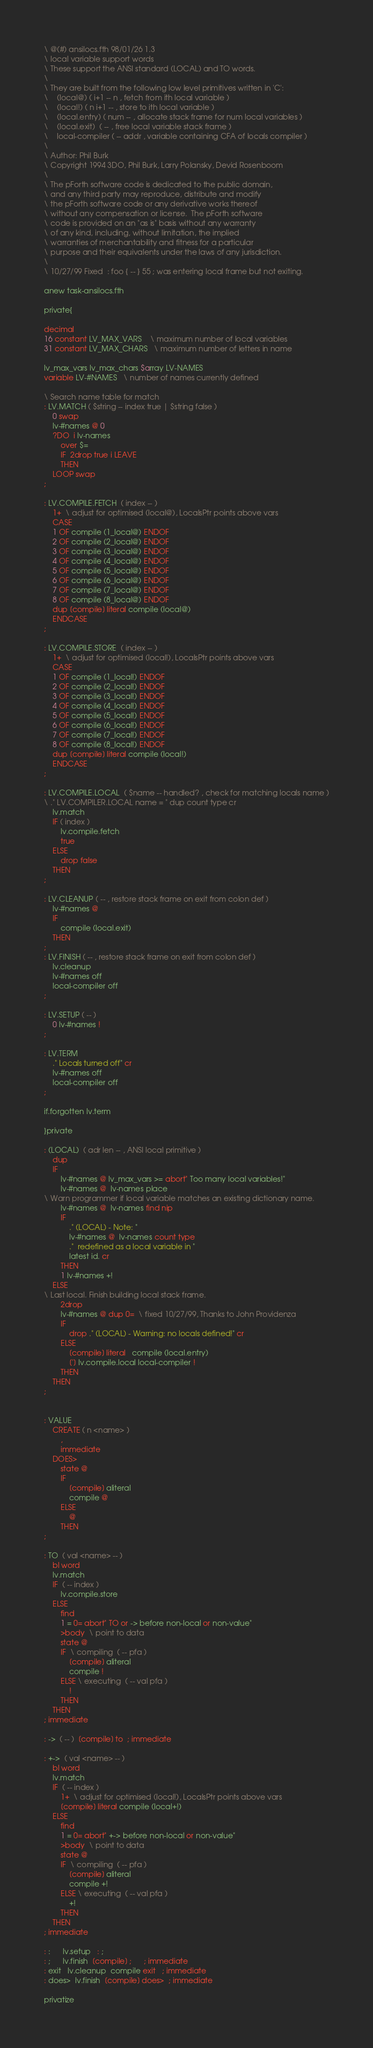Convert code to text. <code><loc_0><loc_0><loc_500><loc_500><_Forth_>\ @(#) ansilocs.fth 98/01/26 1.3
\ local variable support words
\ These support the ANSI standard (LOCAL) and TO words.
\
\ They are built from the following low level primitives written in 'C':
\    (local@) ( i+1 -- n , fetch from ith local variable )
\    (local!) ( n i+1 -- , store to ith local variable )
\    (local.entry) ( num -- , allocate stack frame for num local variables )
\    (local.exit)  ( -- , free local variable stack frame )
\    local-compiler ( -- addr , variable containing CFA of locals compiler )
\
\ Author: Phil Burk
\ Copyright 1994 3DO, Phil Burk, Larry Polansky, Devid Rosenboom
\
\ The pForth software code is dedicated to the public domain,
\ and any third party may reproduce, distribute and modify
\ the pForth software code or any derivative works thereof
\ without any compensation or license.  The pForth software
\ code is provided on an "as is" basis without any warranty
\ of any kind, including, without limitation, the implied
\ warranties of merchantability and fitness for a particular
\ purpose and their equivalents under the laws of any jurisdiction.
\
\ 10/27/99 Fixed  : foo { -- } 55 ; was entering local frame but not exiting.

anew task-ansilocs.fth

private{

decimal
16 constant LV_MAX_VARS    \ maximum number of local variables
31 constant LV_MAX_CHARS   \ maximum number of letters in name

lv_max_vars lv_max_chars $array LV-NAMES
variable LV-#NAMES   \ number of names currently defined

\ Search name table for match
: LV.MATCH ( $string -- index true | $string false )
    0 swap
    lv-#names @ 0
    ?DO  i lv-names
        over $=
        IF  2drop true i LEAVE
        THEN
    LOOP swap
;

: LV.COMPILE.FETCH  ( index -- )
	1+  \ adjust for optimised (local@), LocalsPtr points above vars
	CASE
	1 OF compile (1_local@) ENDOF
	2 OF compile (2_local@) ENDOF
	3 OF compile (3_local@) ENDOF
	4 OF compile (4_local@) ENDOF
	5 OF compile (5_local@) ENDOF
	6 OF compile (6_local@) ENDOF
	7 OF compile (7_local@) ENDOF
	8 OF compile (8_local@) ENDOF
	dup [compile] literal compile (local@)
	ENDCASE
;

: LV.COMPILE.STORE  ( index -- )
	1+  \ adjust for optimised (local!), LocalsPtr points above vars
	CASE
	1 OF compile (1_local!) ENDOF
	2 OF compile (2_local!) ENDOF
	3 OF compile (3_local!) ENDOF
	4 OF compile (4_local!) ENDOF
	5 OF compile (5_local!) ENDOF
	6 OF compile (6_local!) ENDOF
	7 OF compile (7_local!) ENDOF
	8 OF compile (8_local!) ENDOF
	dup [compile] literal compile (local!)
	ENDCASE
;

: LV.COMPILE.LOCAL  ( $name -- handled? , check for matching locals name )
\ ." LV.COMPILER.LOCAL name = " dup count type cr
	lv.match
	IF ( index )
		lv.compile.fetch
		true
	ELSE
		drop false
	THEN
;

: LV.CLEANUP ( -- , restore stack frame on exit from colon def )
	lv-#names @
	IF
		compile (local.exit)
	THEN
;
: LV.FINISH ( -- , restore stack frame on exit from colon def )
	lv.cleanup
	lv-#names off
	local-compiler off
;

: LV.SETUP ( -- )
	0 lv-#names !
;

: LV.TERM
	." Locals turned off" cr
	lv-#names off
	local-compiler off
;

if.forgotten lv.term

}private

: (LOCAL)  ( adr len -- , ANSI local primitive )
	dup
	IF
		lv-#names @ lv_max_vars >= abort" Too many local variables!"
		lv-#names @  lv-names place
\ Warn programmer if local variable matches an existing dictionary name.
		lv-#names @  lv-names find nip
		IF
			." (LOCAL) - Note: "
			lv-#names @  lv-names count type
			."  redefined as a local variable in "
			latest id. cr
		THEN
		1 lv-#names +!
	ELSE
\ Last local. Finish building local stack frame.
		2drop
		lv-#names @ dup 0=  \ fixed 10/27/99, Thanks to John Providenza
		IF
			drop ." (LOCAL) - Warning: no locals defined!" cr
		ELSE
			[compile] literal   compile (local.entry)
			['] lv.compile.local local-compiler !
		THEN
	THEN
;


: VALUE
	CREATE ( n <name> )
		,
		immediate
	DOES>
		state @
		IF
			[compile] aliteral
			compile @
		ELSE
			@
		THEN
;

: TO  ( val <name> -- )
	bl word
	lv.match
	IF  ( -- index )
		lv.compile.store
	ELSE
		find 
		1 = 0= abort" TO or -> before non-local or non-value"
		>body  \ point to data
		state @
		IF  \ compiling  ( -- pfa )
			[compile] aliteral
			compile !
		ELSE \ executing  ( -- val pfa )
			!
		THEN
	THEN
; immediate

: ->  ( -- )  [compile] to  ; immediate

: +->  ( val <name> -- )
	bl word
	lv.match
	IF  ( -- index )
		1+  \ adjust for optimised (local!), LocalsPtr points above vars
		[compile] literal compile (local+!)
	ELSE
		find 
		1 = 0= abort" +-> before non-local or non-value"
		>body  \ point to data
		state @
		IF  \ compiling  ( -- pfa )
			[compile] aliteral
			compile +!
		ELSE \ executing  ( -- val pfa )
			+!
		THEN
	THEN
; immediate

: :      lv.setup   : ;
: ;      lv.finish  [compile] ;      ; immediate
: exit   lv.cleanup  compile exit   ; immediate
: does>  lv.finish  [compile] does>  ; immediate

privatize
</code> 